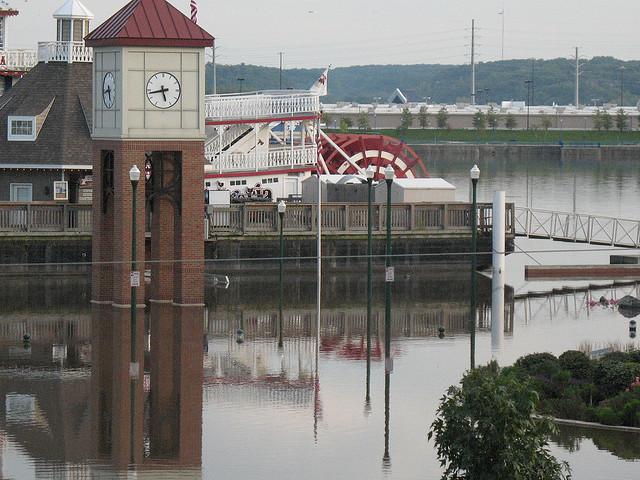How is the boat in the background powered?
Quick response, please. Water. Is this the ocean?
Answer briefly. No. How much longer before it will be 6:00?
Give a very brief answer. 16 minutes. 